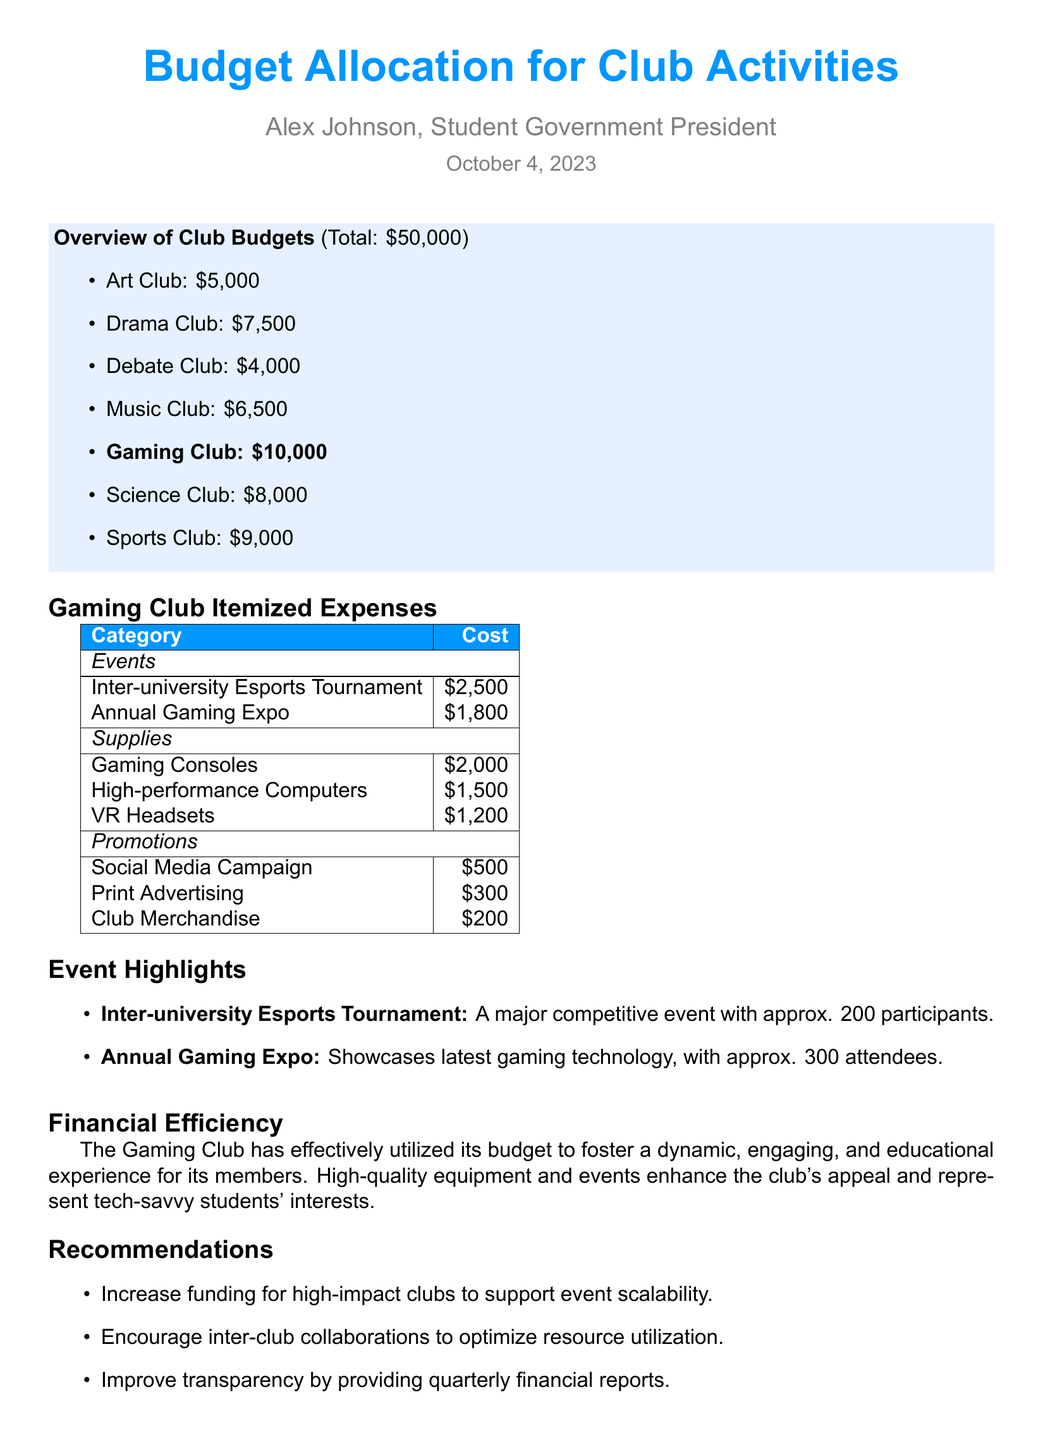What is the total budget allocation? The total budget allocation is provided in the overview section, which states the total amount as $50,000.
Answer: $50,000 How much is allocated to the Gaming Club? The amount allocated to the Gaming Club is directly stated in the overview section as $10,000.
Answer: $10,000 What event had approximately 200 participants? The document mentions that the Inter-university Esports Tournament had approximately 200 participants.
Answer: Inter-university Esports Tournament What is the cost of high-performance computers? The cost of high-performance computers is itemized under supplies in the document as $1,500.
Answer: $1,500 Which expense category has the highest cost? The supplies category has the highest costs totaling $4,700 ($2,000 + $1,500 + $1,200).
Answer: Supplies How much is being spent on promotions? The total spending on promotions is detailed in the document, totaling $1,000 ($500 + $300 + $200).
Answer: $1,000 What recommendation is made regarding funding? The recommendations include an increase in funding for high-impact clubs to support event scalability.
Answer: Increase funding for high-impact clubs What kind of campaign costs $500? The cost for the Social Media Campaign is specifically detailed in the promotions section as $500.
Answer: Social Media Campaign What is the purpose of the Annual Gaming Expo? The document states that the Annual Gaming Expo showcases the latest gaming technology.
Answer: Showcases latest gaming technology 